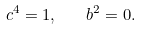Convert formula to latex. <formula><loc_0><loc_0><loc_500><loc_500>c ^ { 4 } = 1 , \quad b ^ { 2 } = 0 .</formula> 